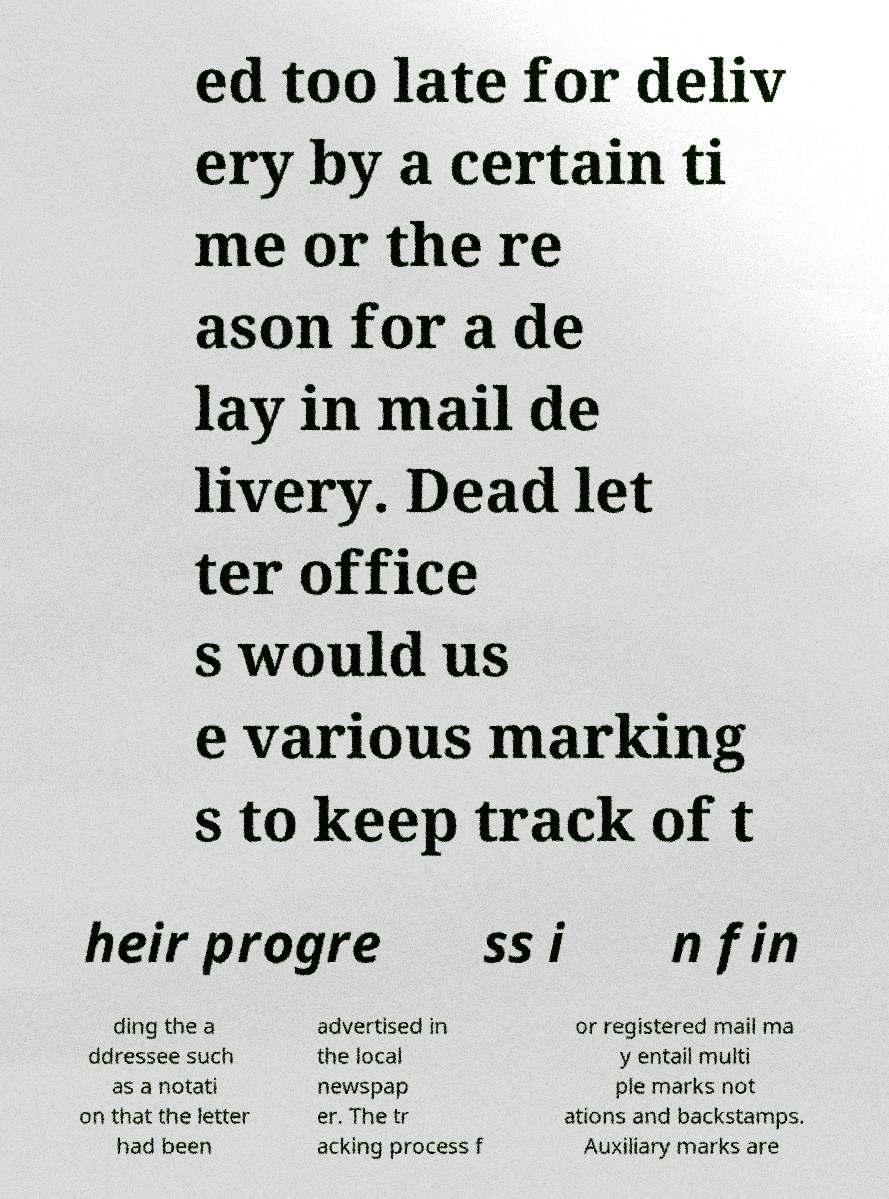I need the written content from this picture converted into text. Can you do that? ed too late for deliv ery by a certain ti me or the re ason for a de lay in mail de livery. Dead let ter office s would us e various marking s to keep track of t heir progre ss i n fin ding the a ddressee such as a notati on that the letter had been advertised in the local newspap er. The tr acking process f or registered mail ma y entail multi ple marks not ations and backstamps. Auxiliary marks are 